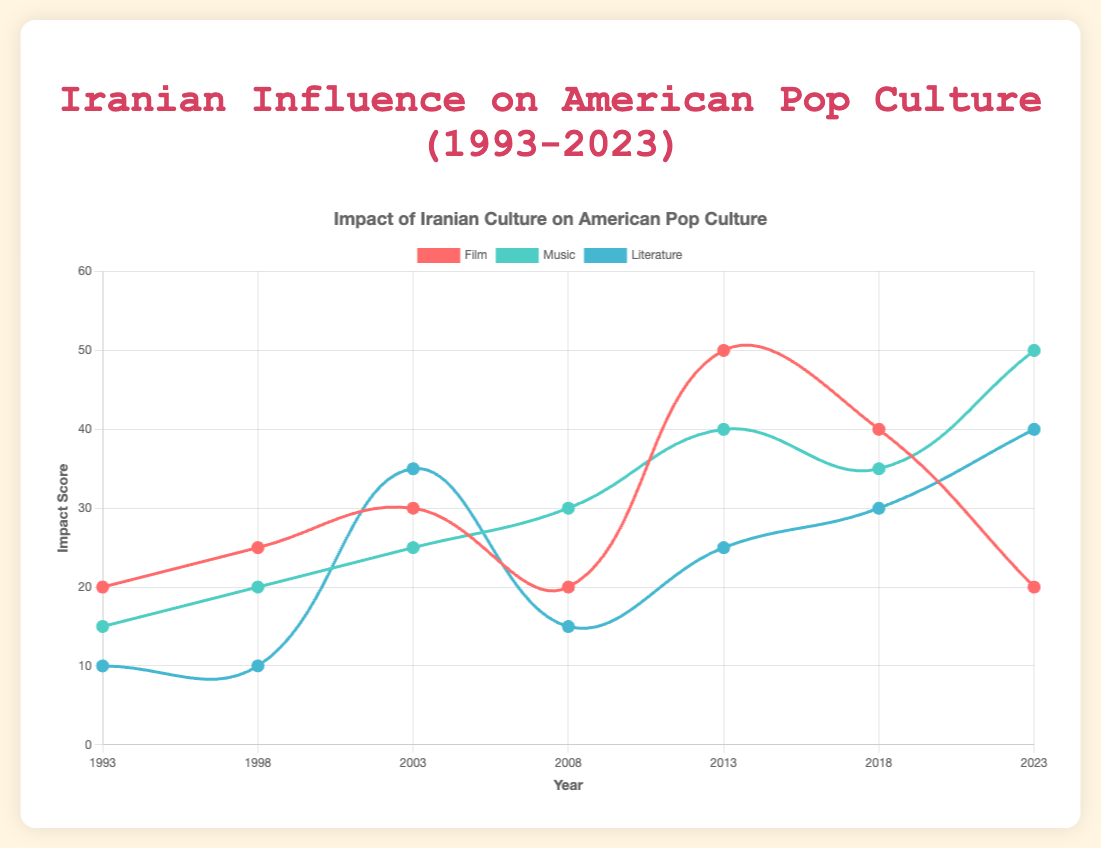What is the total impact score for Film in 2013? To find the total impact score for Film in 2013, locate the datapoint for Film in 2013 on the chart, which is 50.
Answer: 50 Between Music and Literature in 2018, which category had a higher impact score? Compare the impact scores for Music and Literature in 2018 on the chart. Music had a higher impact score with 35 compared to Literature's 30.
Answer: Music What is the average impact score for Literature over the 30 years? Sum the impact scores for Literature across the years and divide by the number of years: (10 + 10 + 35 + 15 + 25 + 30 + 40) / 7 = 165 / 7 ≈ 23.57.
Answer: 23.57 Which year had the highest impact score for Film and what was it? Find the peak point on the Film line; it occurred in 2013 with an impact score of 50.
Answer: 2013, 50 How does the impact score of Music in 2023 compare to its impact score in 1993? Locate the impact scores for Music in 2023 and 1993 on the chart (50 and 15, respectively). 2023 has a higher score by 35 points.
Answer: 2023 is higher by 35 What is the difference in impact scores between Music and Film in 1998? Subtract the impact score of Film from that of Music in 1998: 20 - 25 = -5.
Answer: -5 Which categories saw an increase in their impact scores from 2008 to 2013? Compare the impact scores of each category between 2008 and 2013. Both Film (20 to 50), Music (30 to 40), and Literature (15 to 25) saw increases.
Answer: Film, Music, Literature How many times did the impact score for Literature surpass that of Film from 1993 to 2023? Compare the impact scores of Literature and Film for each year. Literature surpassed Film in 2003, 2018, and 2023.
Answer: 3 times 